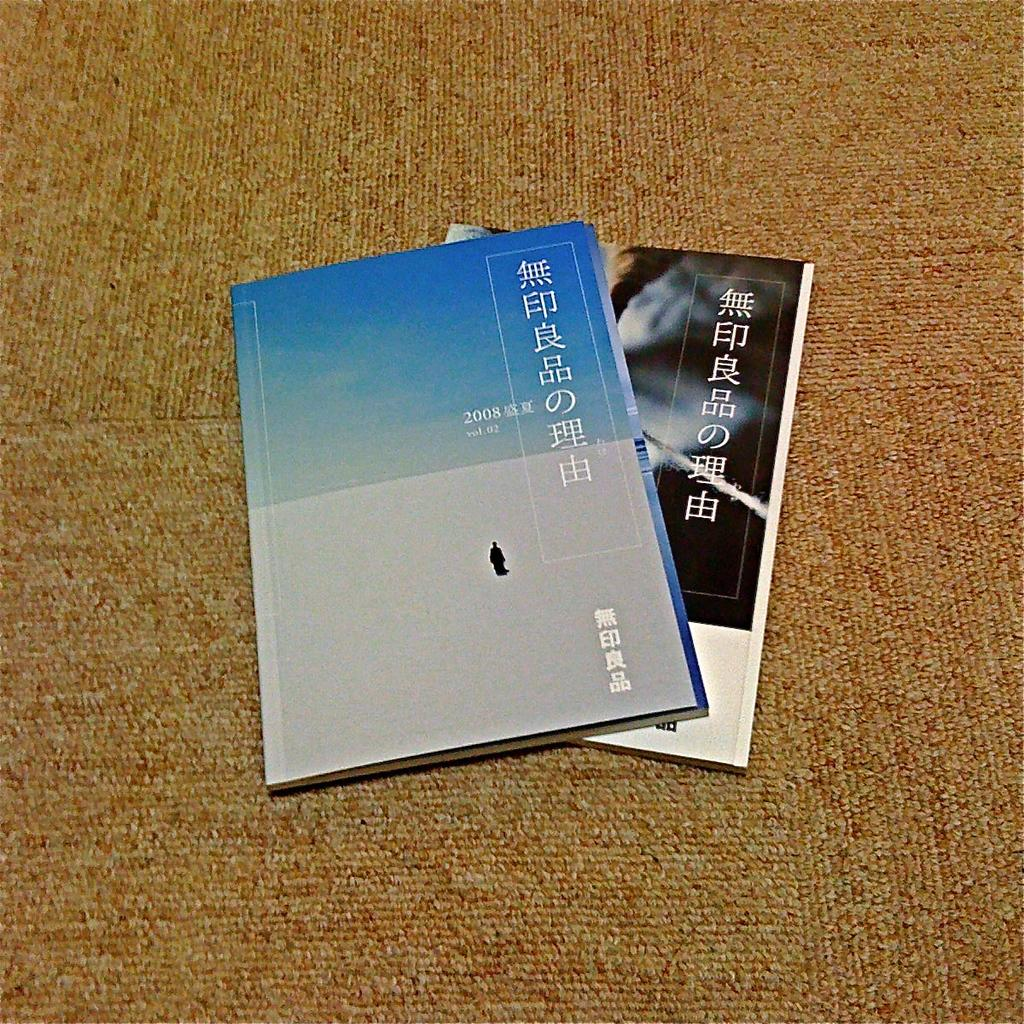<image>
Offer a succinct explanation of the picture presented. A blue book with the year 2008 on it is lying over another book. 